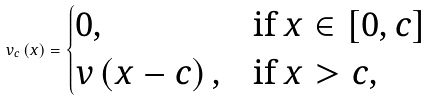Convert formula to latex. <formula><loc_0><loc_0><loc_500><loc_500>v _ { c } \left ( x \right ) = \begin{cases} 0 , & \text {if } x \in [ 0 , c ] \\ v \left ( x - c \right ) , & \text {if } x > c , \\ \end{cases}</formula> 